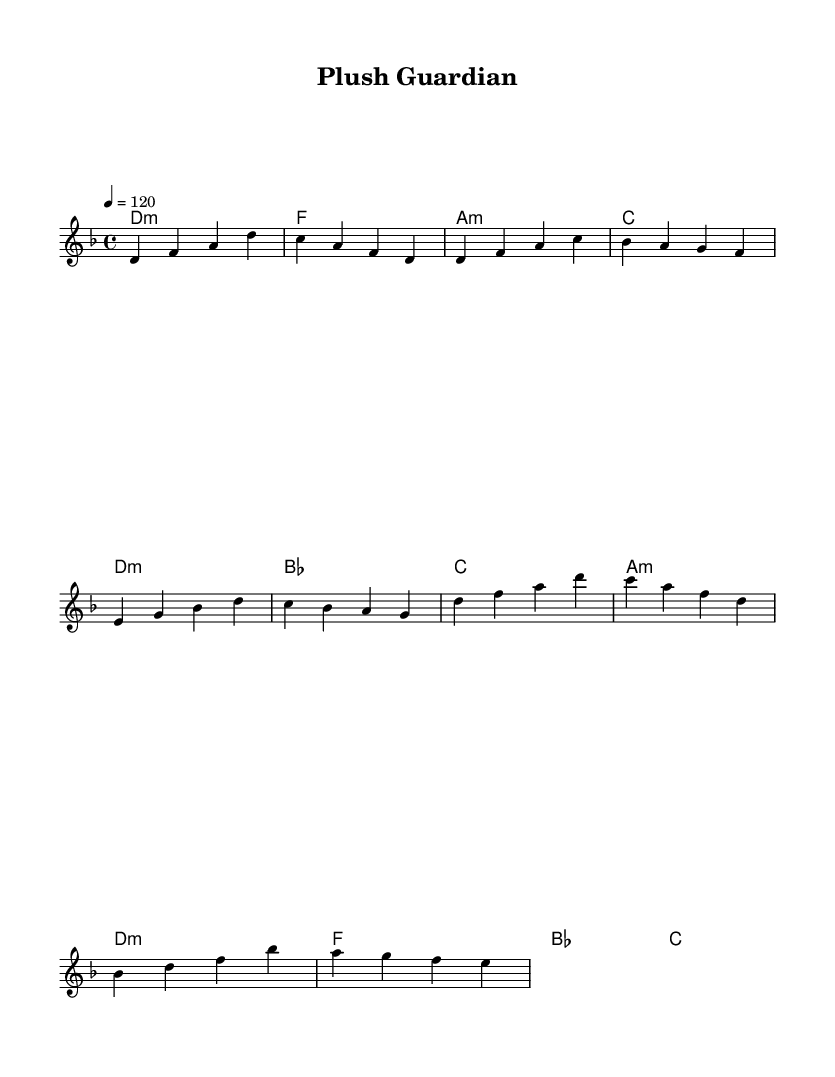What is the key signature of this music? The key signature is D minor, indicated by one flat in the music notation.
Answer: D minor What is the time signature of this piece? The time signature is 4/4, which is shown at the beginning of the score.
Answer: 4/4 What is the tempo marking for this music? The tempo marking indicates a speed of 120 beats per minute, as noted in the score.
Answer: 120 What is the name of this piece? The title "Plush Guardian" is listed in the header section of the score.
Answer: Plush Guardian What is the structure of the music based on the score? The score is structured with an intro, verse, and chorus, as indicated by their respective sections in the melody.
Answer: Intro, verse, chorus Which chord is used most frequently in the verse? The D minor chord is used most frequently throughout the verse sections of the piece.
Answer: D minor How does the chorus differ from the verse in terms of harmony? The chorus introduces a different progression with a focus on the B flat chord, showing a shift in harmony compared to the verse's progression.
Answer: B flat 